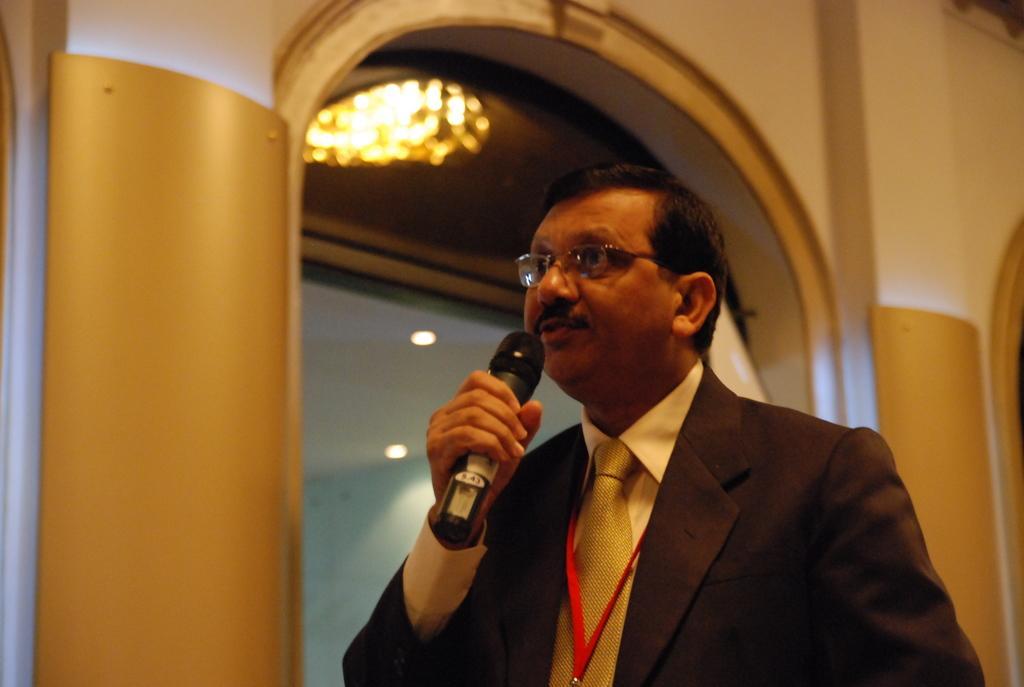Can you describe this image briefly? In this image the person is holding the mike wearing the brown coat,light yellow shirt,yellow tie,red tag and specks behind the person some building is there and some light. 